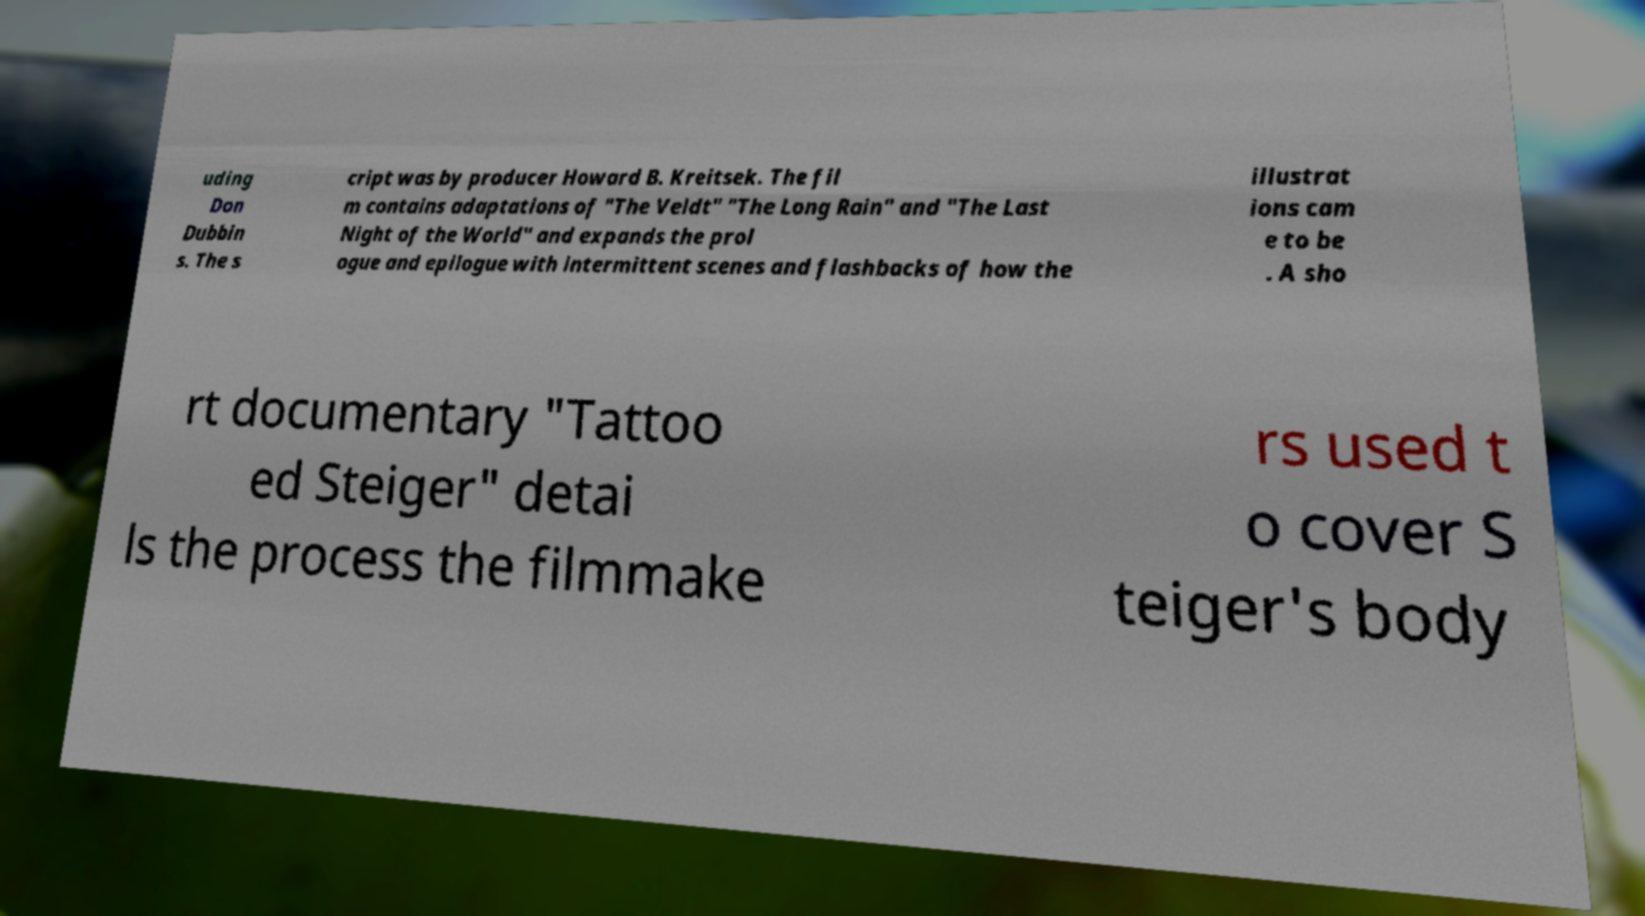There's text embedded in this image that I need extracted. Can you transcribe it verbatim? uding Don Dubbin s. The s cript was by producer Howard B. Kreitsek. The fil m contains adaptations of "The Veldt" "The Long Rain" and "The Last Night of the World" and expands the prol ogue and epilogue with intermittent scenes and flashbacks of how the illustrat ions cam e to be . A sho rt documentary "Tattoo ed Steiger" detai ls the process the filmmake rs used t o cover S teiger's body 